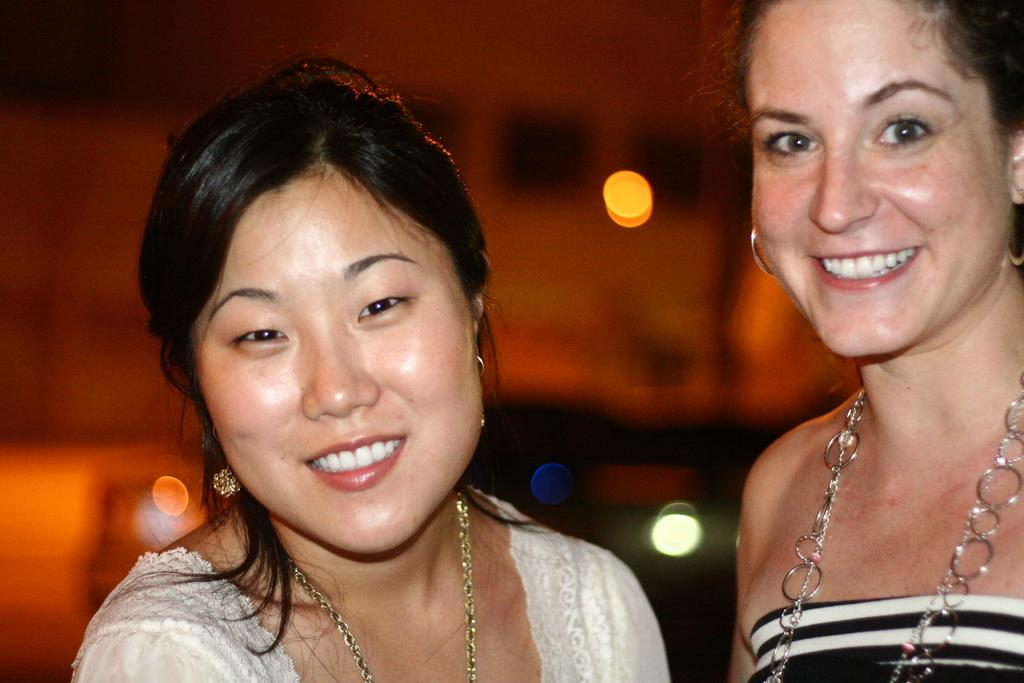How many women are in the image? There are two women in the image. What are the women doing in the image? The women are smiling. What type of jewelry are the women wearing? Both women are wearing necklaces and earrings. Can you describe the background of the image? The background of the image is blurry. What type of force is being applied to the arm in the image? There is no arm present in the image, and therefore no force is being applied. What type of music can be heard in the background of the image? There is no music present in the image, as it is a still photograph. 